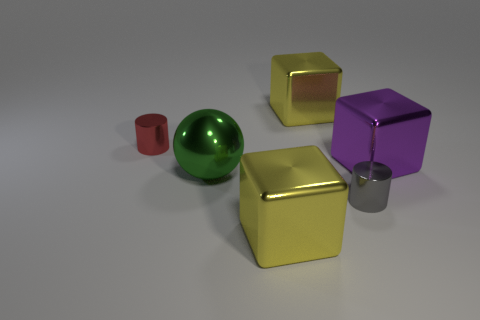What number of things are either large green things or large red matte objects?
Offer a terse response. 1. What is the shape of the yellow thing that is in front of the yellow shiny cube behind the cylinder that is behind the gray metallic cylinder?
Your answer should be very brief. Cube. Are the large ball that is on the right side of the tiny red object and the cylinder to the right of the red shiny cylinder made of the same material?
Your answer should be compact. Yes. What material is the tiny gray object that is the same shape as the small red object?
Give a very brief answer. Metal. Is there any other thing that is the same size as the gray thing?
Give a very brief answer. Yes. Does the tiny object that is right of the red metallic thing have the same shape as the yellow shiny object in front of the gray cylinder?
Offer a terse response. No. Are there fewer tiny gray metal things that are behind the tiny red metal cylinder than green objects in front of the gray metallic thing?
Your answer should be very brief. No. How many other things are there of the same shape as the green metallic object?
Your answer should be very brief. 0. What is the shape of the gray object that is made of the same material as the red cylinder?
Provide a short and direct response. Cylinder. There is a big block that is in front of the red metallic thing and behind the green object; what is its color?
Your answer should be very brief. Purple. 